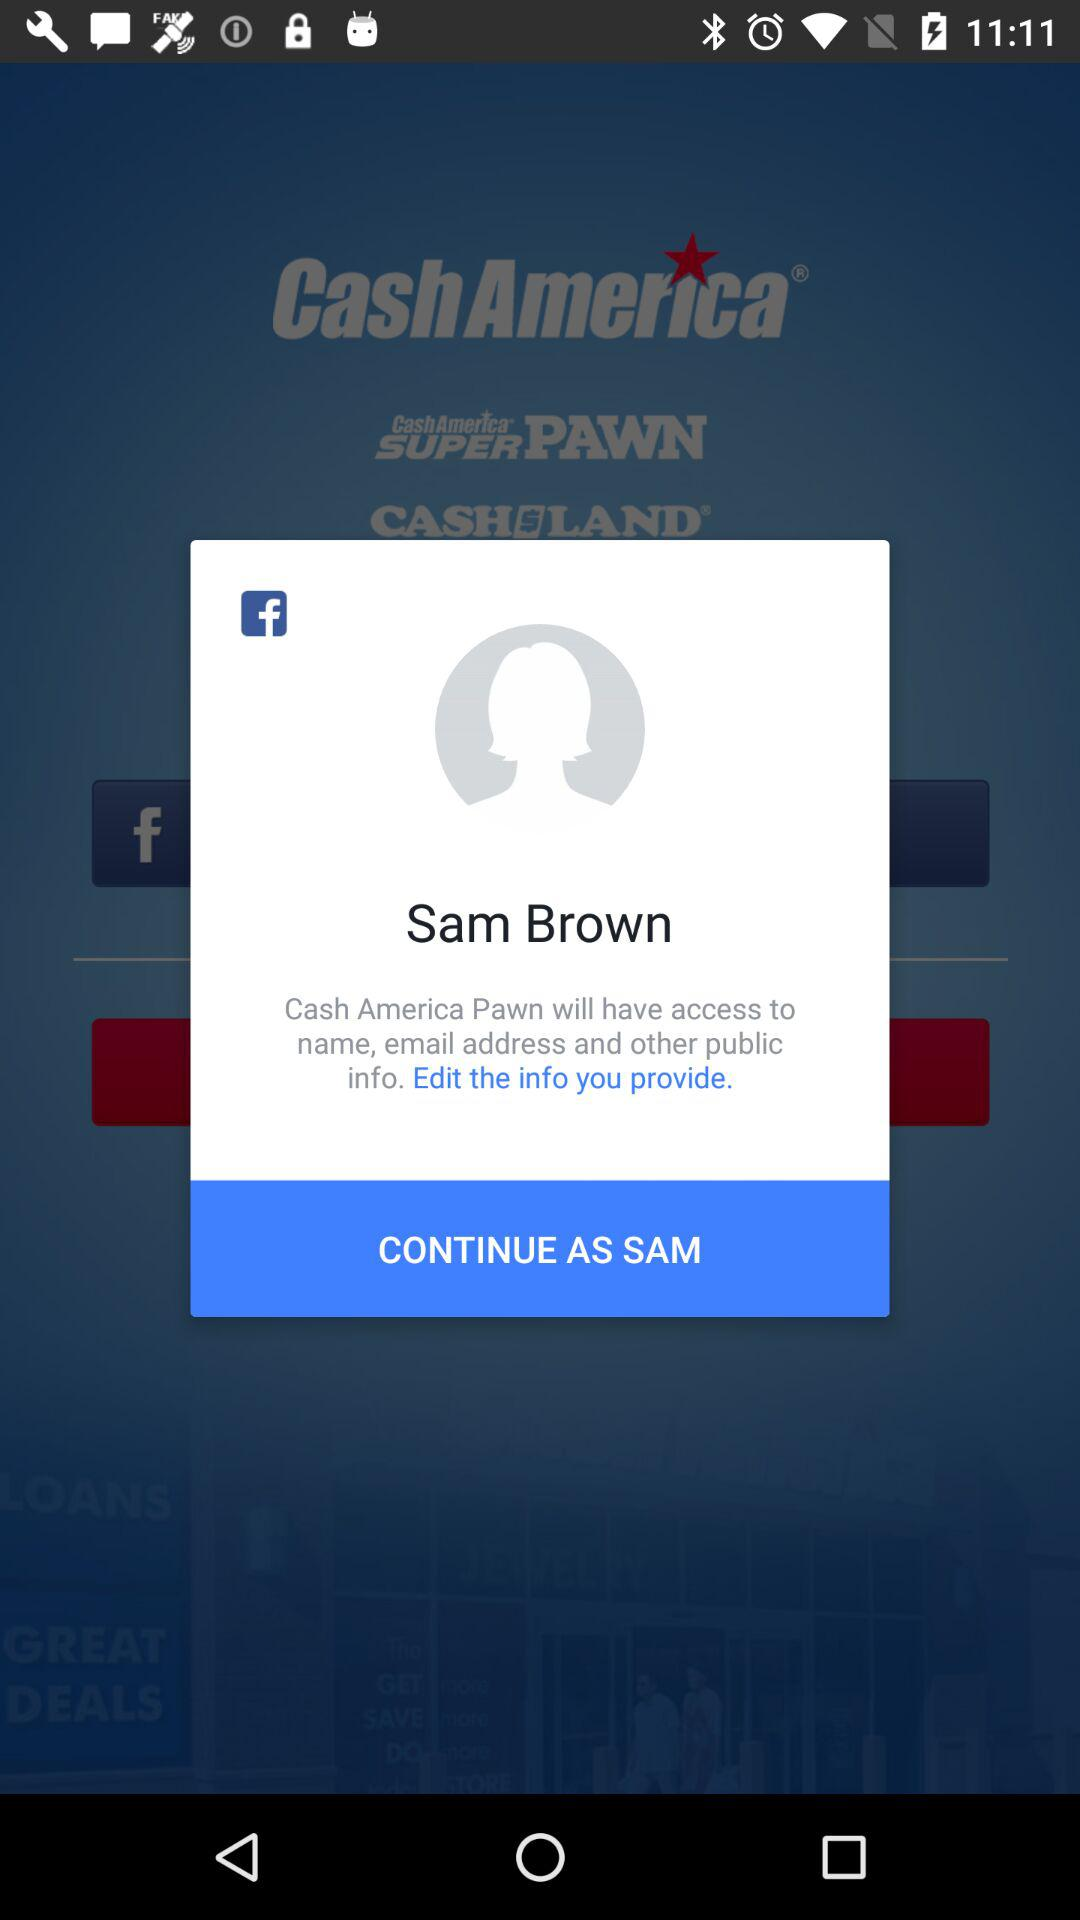What is the user name? The user name is Sam Brown. 